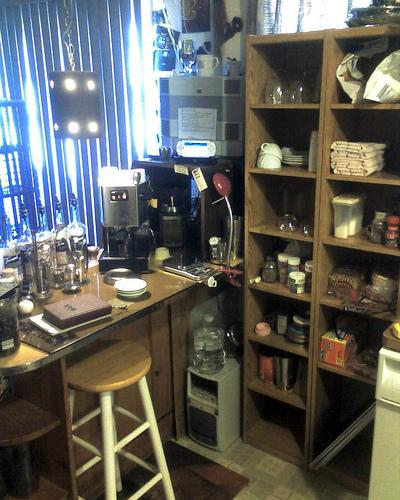List some items related to drink preparation displayed on the counter and shelf. Coffee maker, flavored syrup bottles, white mugs, water jug, and small canister of sugar. Write a sentence describing some objects on the shelf. The wooden shelf is full of diverse items, such as spices, stacked dish towels, and a group of towels. Create a short narrative about an action happening involving the lamp in the image. The small red desk lamp was placed delicately by the white mugs, providing a warm glow in the dimly-lit kitchen. Imagine what someone might do with the stack of plates and describe that scene. A person could grab a plate from the stack by the mugs to prepare a delicious meal and enjoy a warm drink. Describe the seating arrangement visible in the image. A brown barstool with a white cushion is tucked under the counter, providing a comfortable spot to sit and enjoy a meal. Express the overall atmosphere of the scene depicted in the image. The cozy kitchen scene showcases a variety of items on the counter and shelf, offering a charming and homey feel. Mention some important items that can be found on the counter. On the cluttered counter, there's an old book, a coffee maker, and bottles of flavored syrup. Identify an object in the image that seems out of place and describe it. The red cased book, placed on the cluttered counter, appears out of place among the kitchen items and supplies. Provide a brief description of the most significant object in the image. A tall wooden chair is positioned under the counter, ready for use. Describe the scene involving the coffee-related objects in the image. A silver coffee maker is placed on the counter next to stackable white mugs, perfect for serving fresh coffee. 